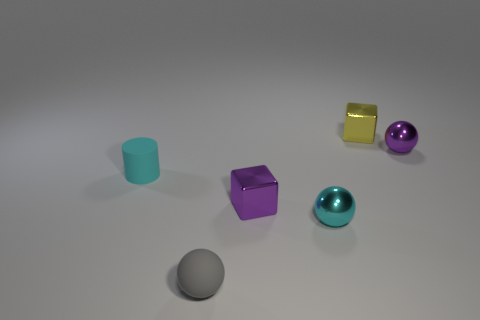What color is the small cube in front of the tiny purple metallic thing behind the cyan cylinder?
Provide a short and direct response. Purple. What number of spheres are either gray things or tiny cyan shiny things?
Your answer should be compact. 2. There is a metallic sphere left of the tiny metal cube that is behind the tiny cyan cylinder; how many tiny cyan shiny things are to the left of it?
Ensure brevity in your answer.  0. What size is the metal ball that is the same color as the matte cylinder?
Give a very brief answer. Small. Are there any small yellow things made of the same material as the cyan sphere?
Give a very brief answer. Yes. Does the cylinder have the same material as the small purple sphere?
Your answer should be very brief. No. There is a small shiny block that is left of the yellow cube; what number of small purple metallic spheres are left of it?
Give a very brief answer. 0. What number of cyan things are either metallic balls or tiny blocks?
Your answer should be very brief. 1. What is the shape of the tiny purple thing that is to the right of the block that is behind the sphere that is behind the cyan matte thing?
Give a very brief answer. Sphere. What is the color of the other metallic sphere that is the same size as the purple sphere?
Provide a short and direct response. Cyan. 